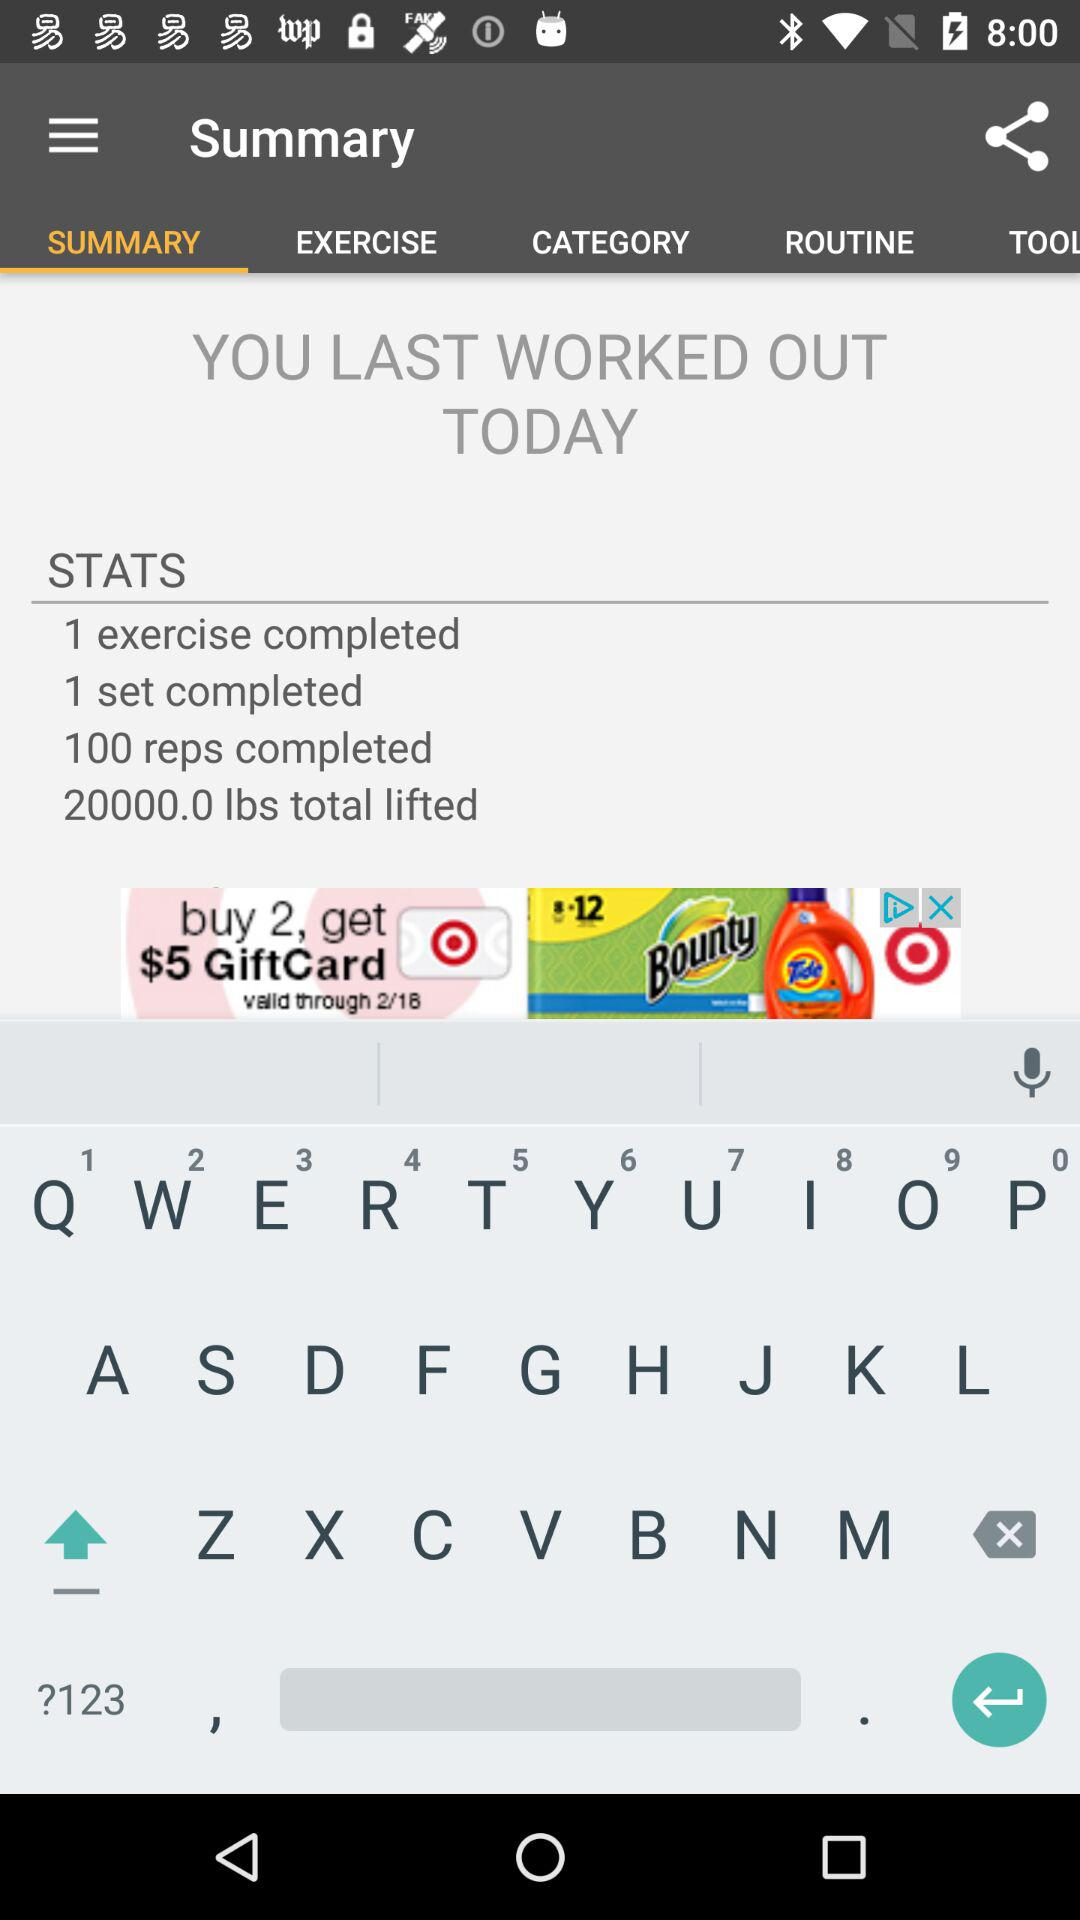Is there an award or achievement mentioned for completing the workout? No, the image of the workout summary does not mention any awards or achievements for completing the workout. 